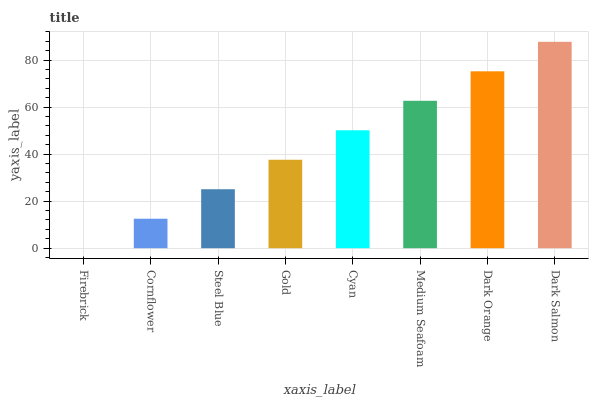Is Firebrick the minimum?
Answer yes or no. Yes. Is Dark Salmon the maximum?
Answer yes or no. Yes. Is Cornflower the minimum?
Answer yes or no. No. Is Cornflower the maximum?
Answer yes or no. No. Is Cornflower greater than Firebrick?
Answer yes or no. Yes. Is Firebrick less than Cornflower?
Answer yes or no. Yes. Is Firebrick greater than Cornflower?
Answer yes or no. No. Is Cornflower less than Firebrick?
Answer yes or no. No. Is Cyan the high median?
Answer yes or no. Yes. Is Gold the low median?
Answer yes or no. Yes. Is Gold the high median?
Answer yes or no. No. Is Dark Salmon the low median?
Answer yes or no. No. 